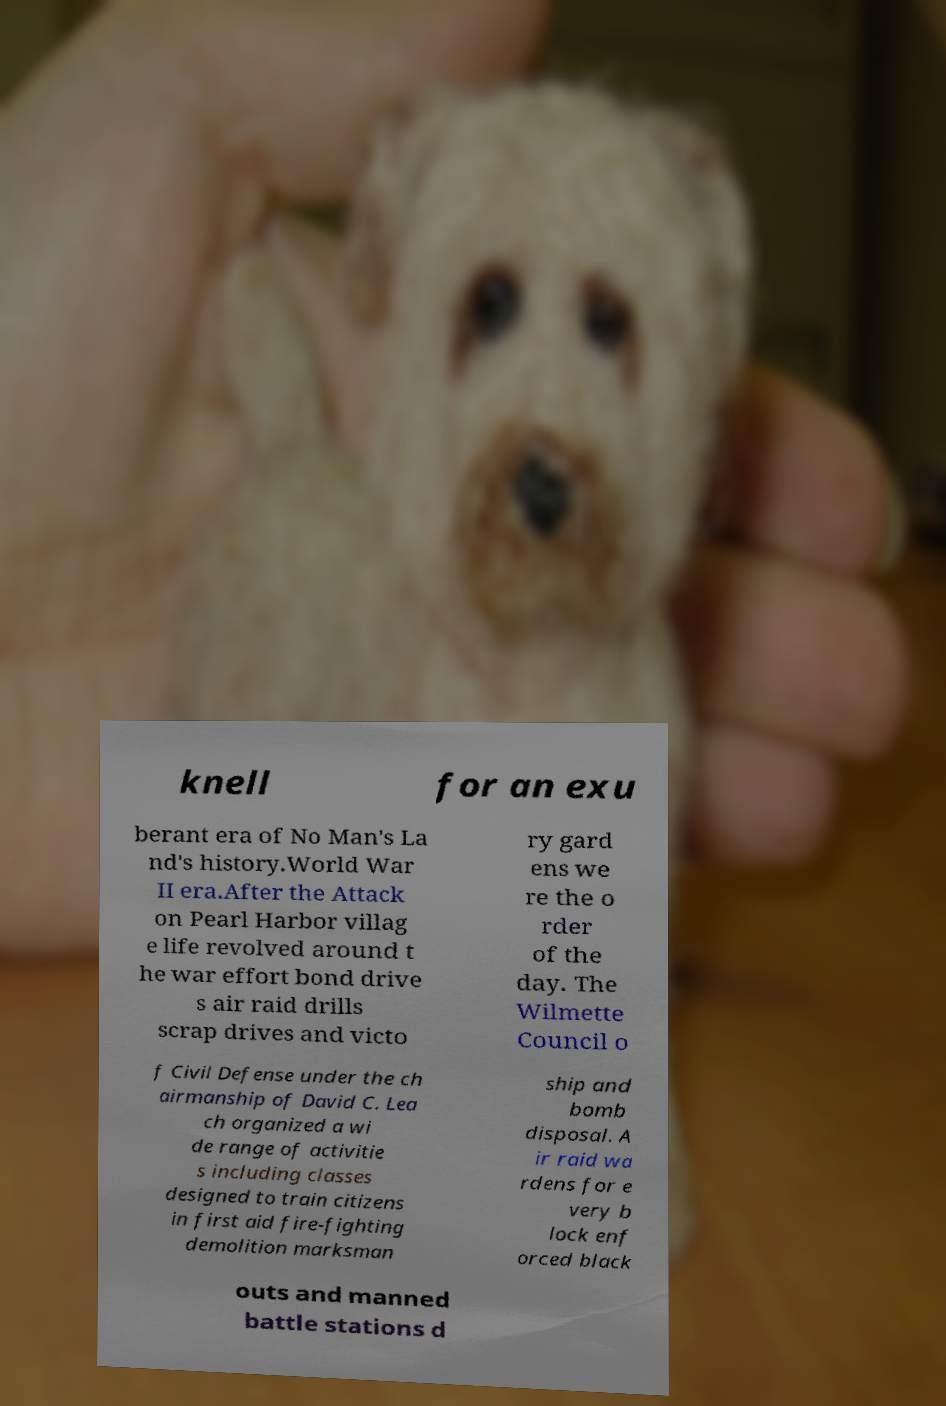What messages or text are displayed in this image? I need them in a readable, typed format. knell for an exu berant era of No Man's La nd's history.World War II era.After the Attack on Pearl Harbor villag e life revolved around t he war effort bond drive s air raid drills scrap drives and victo ry gard ens we re the o rder of the day. The Wilmette Council o f Civil Defense under the ch airmanship of David C. Lea ch organized a wi de range of activitie s including classes designed to train citizens in first aid fire-fighting demolition marksman ship and bomb disposal. A ir raid wa rdens for e very b lock enf orced black outs and manned battle stations d 